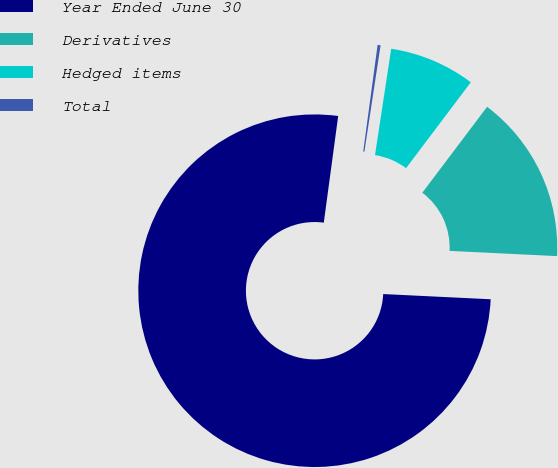Convert chart to OTSL. <chart><loc_0><loc_0><loc_500><loc_500><pie_chart><fcel>Year Ended June 30<fcel>Derivatives<fcel>Hedged items<fcel>Total<nl><fcel>76.37%<fcel>15.49%<fcel>7.88%<fcel>0.27%<nl></chart> 